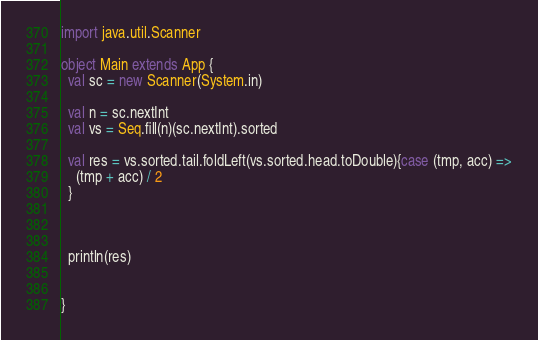Convert code to text. <code><loc_0><loc_0><loc_500><loc_500><_Scala_>import java.util.Scanner

object Main extends App {
  val sc = new Scanner(System.in)

  val n = sc.nextInt
  val vs = Seq.fill(n)(sc.nextInt).sorted

  val res = vs.sorted.tail.foldLeft(vs.sorted.head.toDouble){case (tmp, acc) =>
    (tmp + acc) / 2
  }



  println(res)


}
</code> 